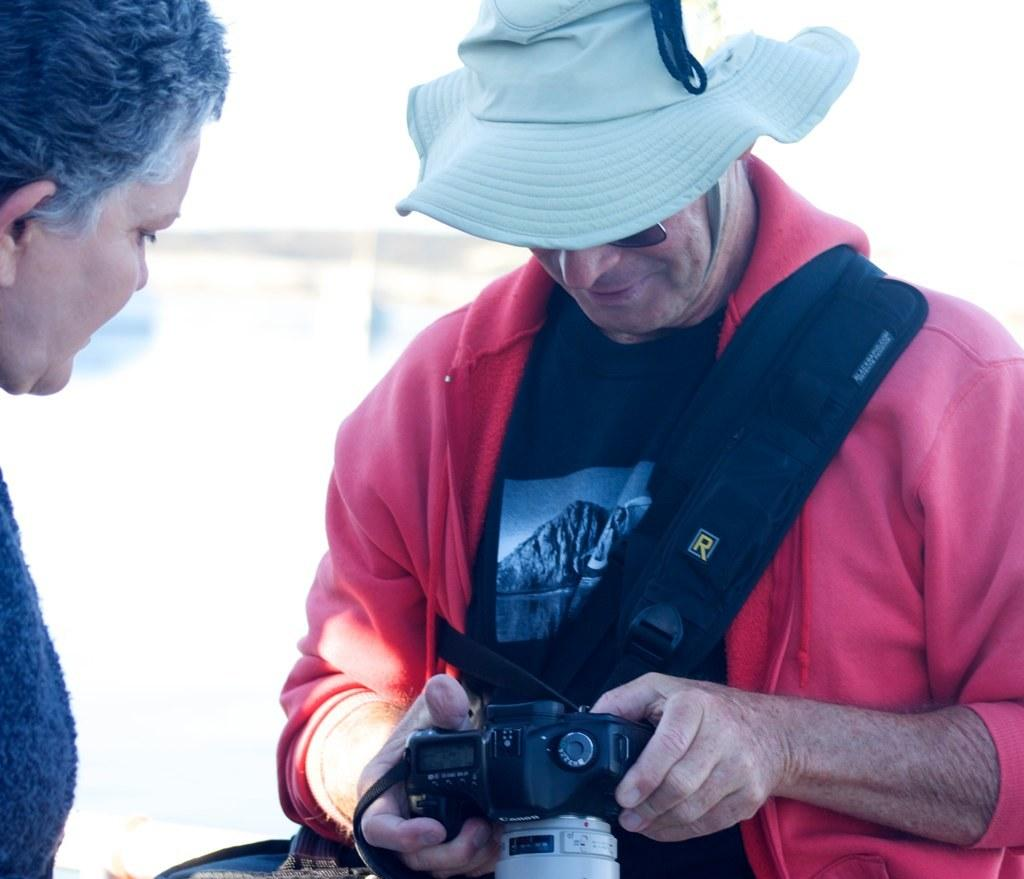What is the man in the image holding? The man is holding a camera in his hand. What is the man doing with the camera? The man is looking into the camera. Who else is in the image? There is a woman in the image. What is the woman doing? The woman is also looking into the camera. What is the man wearing on his head? The man is wearing a hat. What type of jelly is the man eating in the image? There is no jelly present in the image; the man is holding a camera and wearing a hat. 